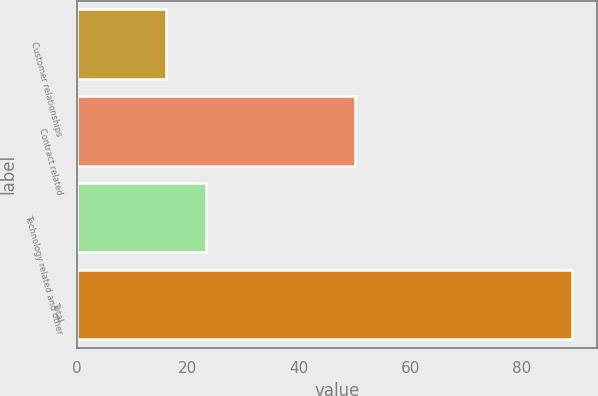<chart> <loc_0><loc_0><loc_500><loc_500><bar_chart><fcel>Customer relationships<fcel>Contract related<fcel>Technology related and other<fcel>Total<nl><fcel>16<fcel>50<fcel>23.3<fcel>89<nl></chart> 